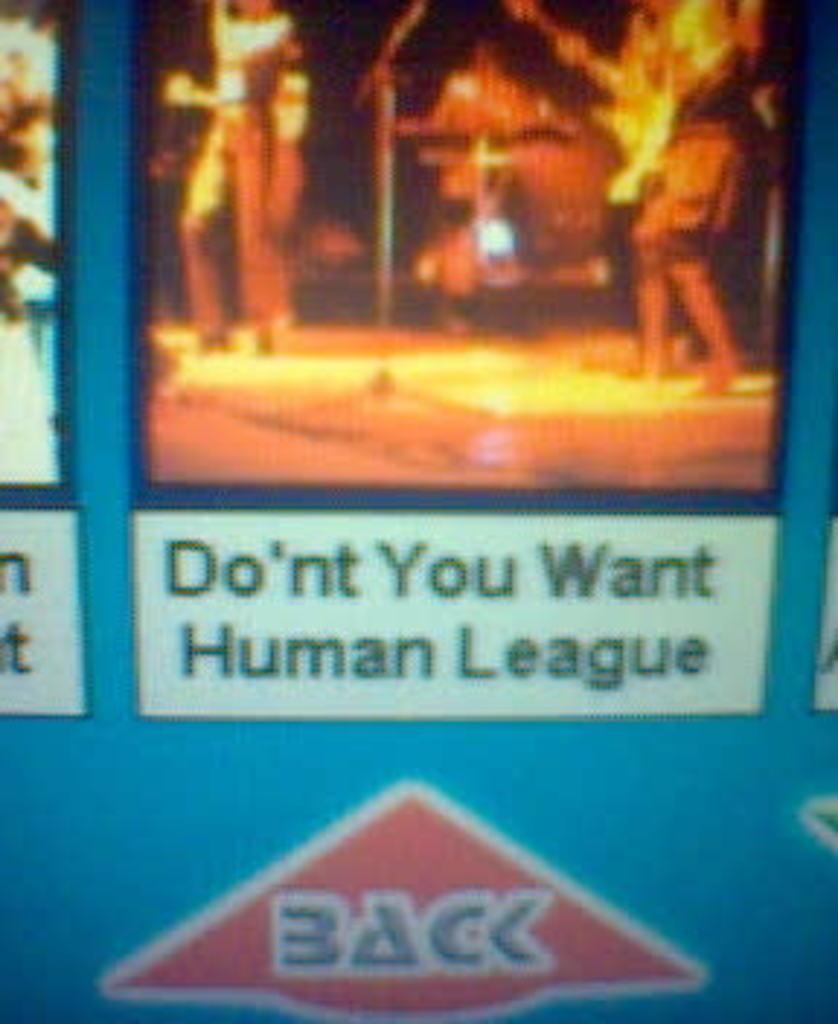In one or two sentences, can you explain what this image depicts? This image consists of a screen. In which there are humans. It looks like it is clicked on the screen. 